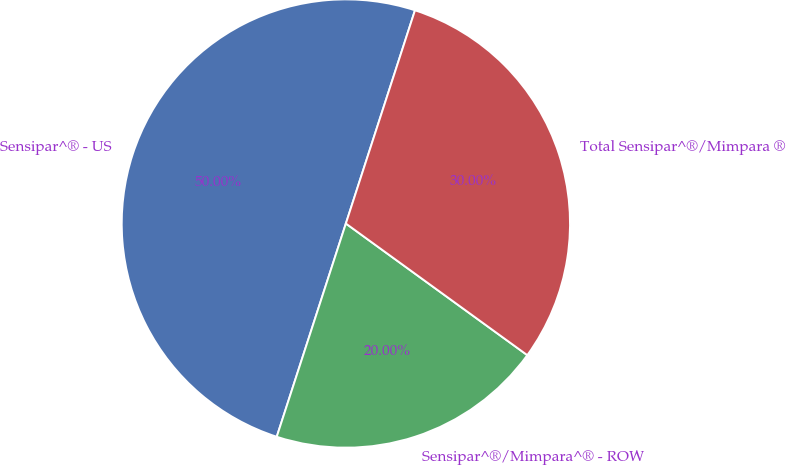Convert chart to OTSL. <chart><loc_0><loc_0><loc_500><loc_500><pie_chart><fcel>Sensipar^® - US<fcel>Sensipar^®/Mimpara^® - ROW<fcel>Total Sensipar^®/Mimpara ®<nl><fcel>50.0%<fcel>20.0%<fcel>30.0%<nl></chart> 